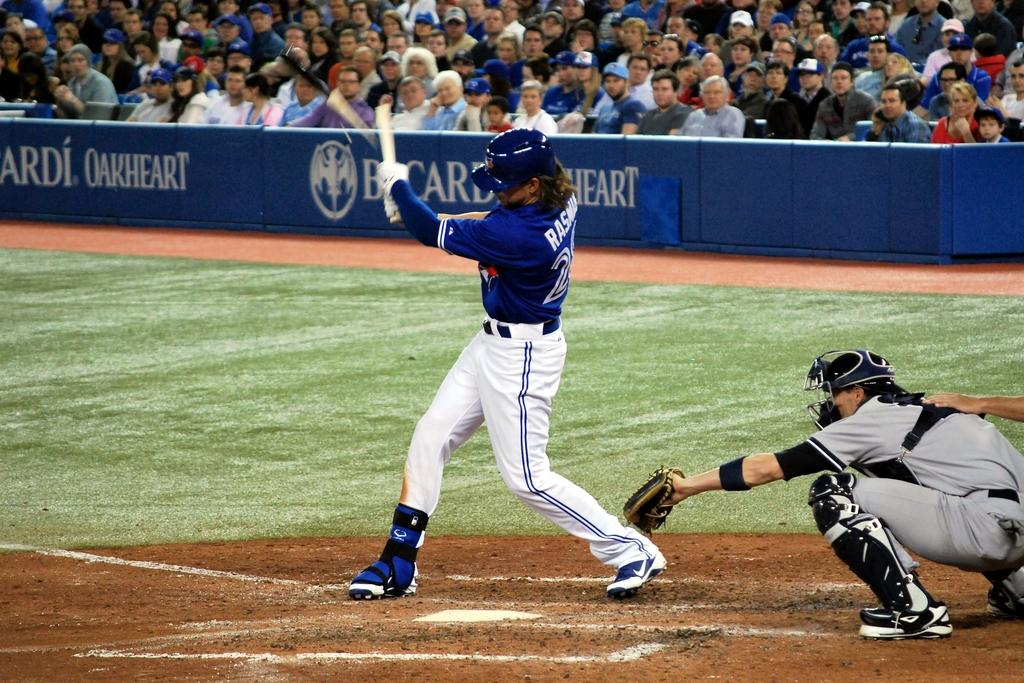<image>
Offer a succinct explanation of the picture presented. A baseball player swings his bat in front of a stadium ad for Bacardi Oakheart. 